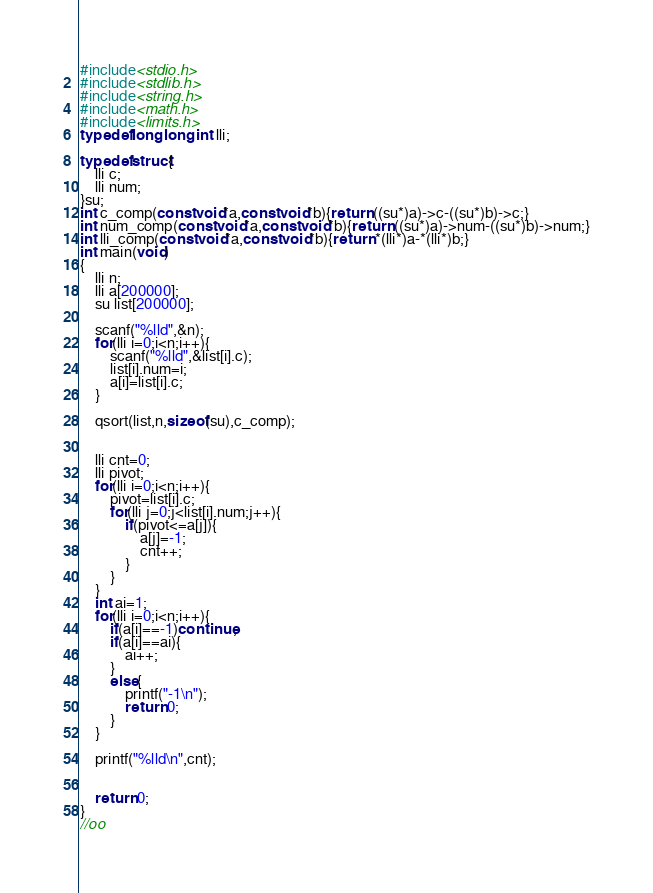<code> <loc_0><loc_0><loc_500><loc_500><_C_>#include<stdio.h>
#include<stdlib.h>
#include<string.h>
#include<math.h>
#include<limits.h>
typedef long long int lli;

typedef struct{
    lli c;
    lli num;
}su;
int c_comp(const void*a,const void*b){return ((su*)a)->c-((su*)b)->c;}
int num_comp(const void*a,const void*b){return ((su*)a)->num-((su*)b)->num;}
int lli_comp(const void*a,const void*b){return *(lli*)a-*(lli*)b;}
int main(void)
{
    lli n;
    lli a[200000];
    su list[200000];

    scanf("%lld",&n);
    for(lli i=0;i<n;i++){
        scanf("%lld",&list[i].c);
        list[i].num=i;
        a[i]=list[i].c;
    }

    qsort(list,n,sizeof(su),c_comp);

    
    lli cnt=0;
    lli pivot;
    for(lli i=0;i<n;i++){
        pivot=list[i].c;
        for(lli j=0;j<list[i].num;j++){
            if(pivot<=a[j]){
                a[j]=-1;
                cnt++;
            }
        }
    }
    int ai=1;
    for(lli i=0;i<n;i++){
        if(a[i]==-1)continue;
        if(a[i]==ai){
            ai++;
        }
        else{
            printf("-1\n");
            return 0;
        }
    }
    
    printf("%lld\n",cnt);

        
    return 0;
}
//oo</code> 